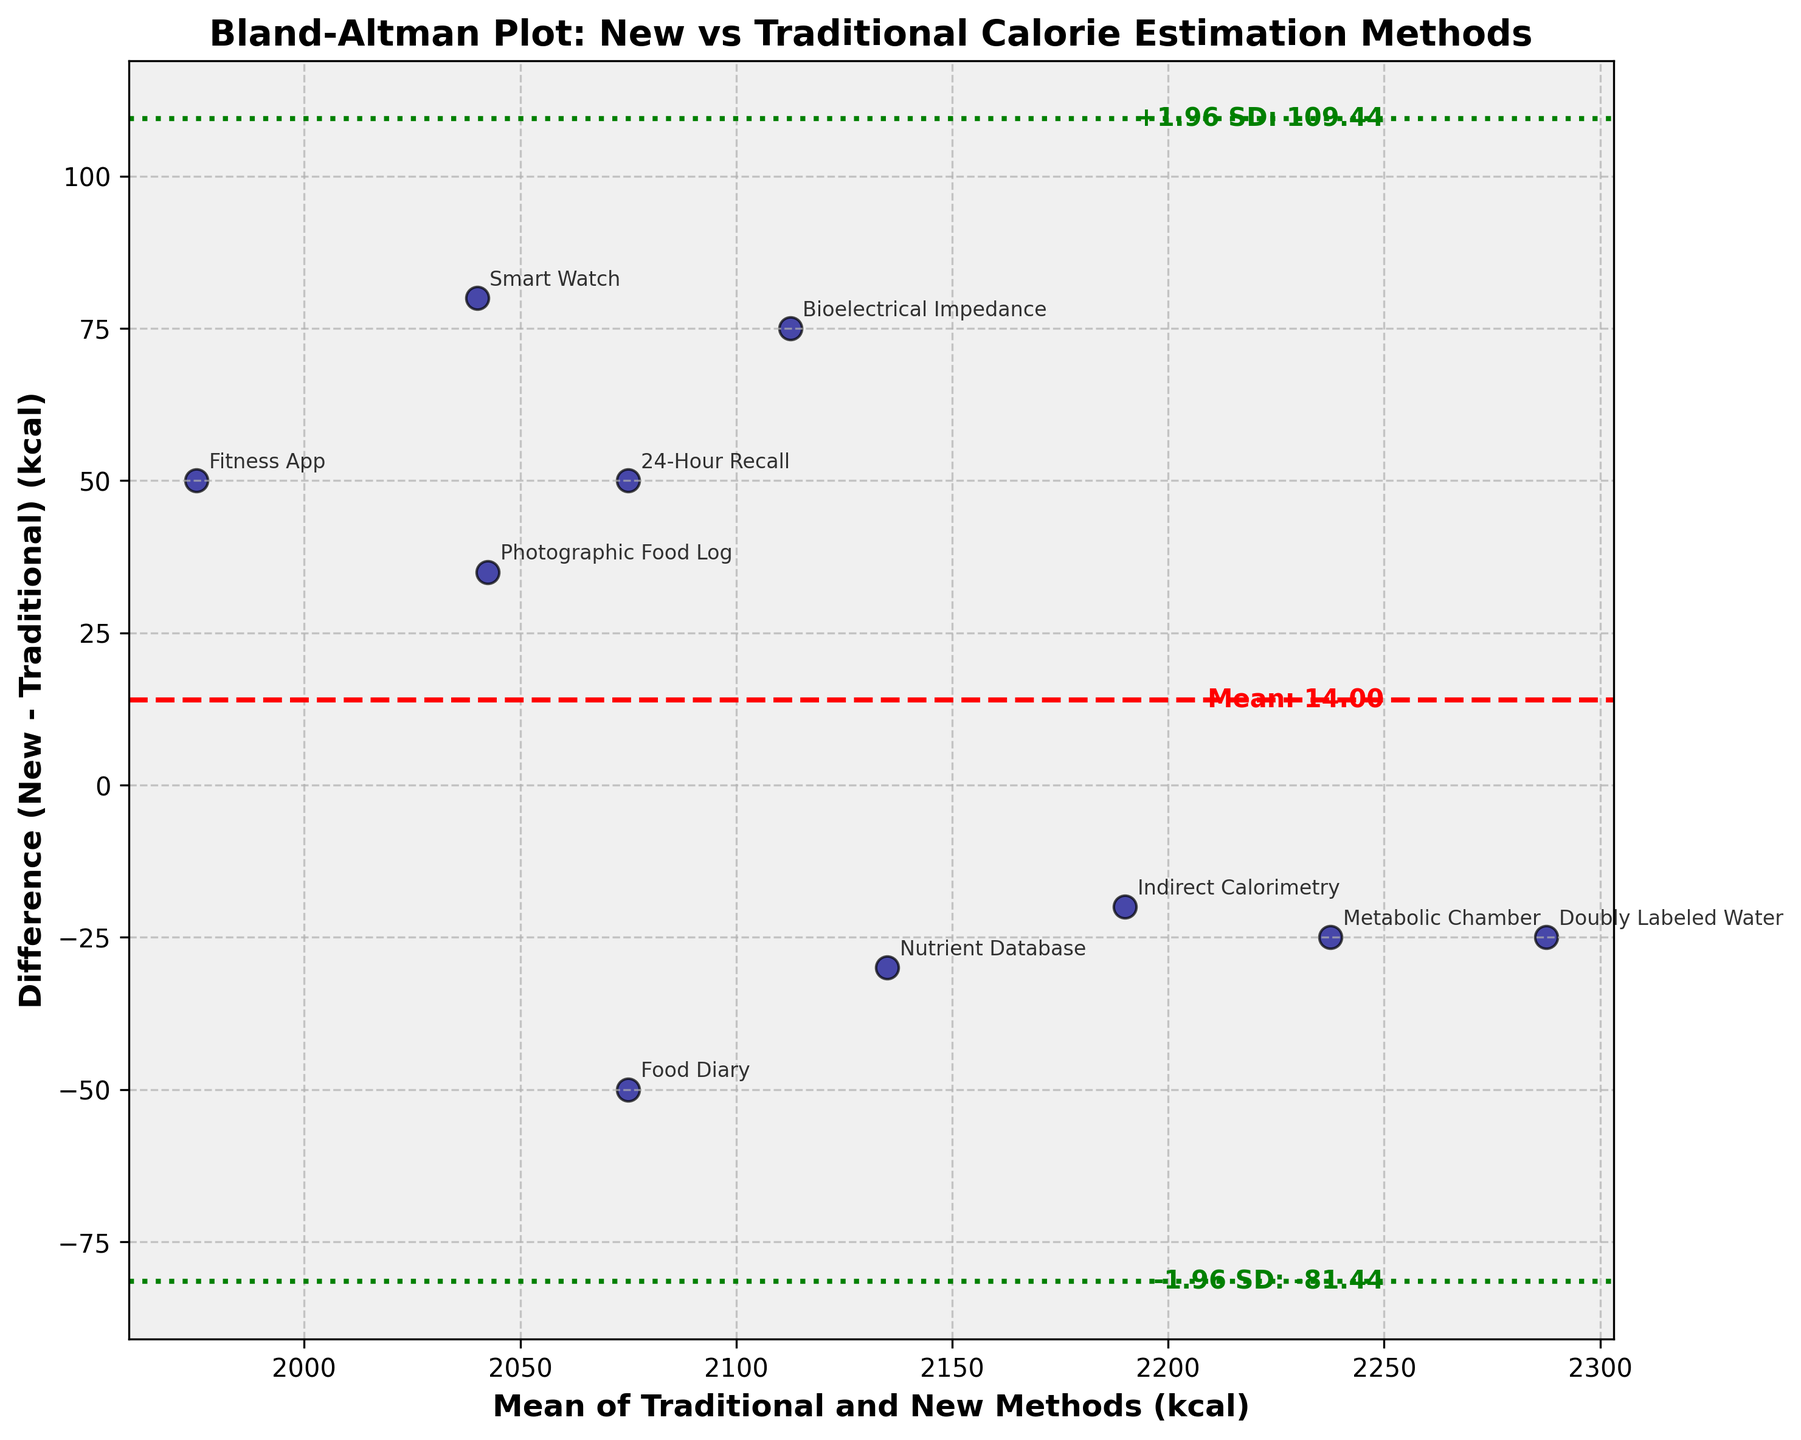What is the title of the plot? The title of the plot is usually found at the top and describes what the figure is about. Here, since the data compares new and traditional methods of estimating daily calorie intake, the title reflects this comparison.
Answer: Bland-Altman Plot: New vs Traditional Calorie Estimation Methods How many data points are plotted in the figure? To determine the number of data points, count the number of markers or points shown in the plot. Each point represents a pair of measurements from the dataset.
Answer: 10 What is the average difference between the new and traditional methods? The average difference is shown as a horizontal dashed red line in the plot. It is also annotated with "Mean" next to it.
Answer: -5.50 What do the green dotted lines represent? The green dotted lines represent the limits of agreement, which are ±1.96 times the standard deviation of the differences from the mean of the differences. These lines help determine the range within which most differences between the two methods lie.
Answer: Limits of agreement What is the range of the limits of agreement? The limits of agreement are calculated as Mean ± 1.96 * SD. These values are marked by green dotted lines and annotated on the plot.
Answer: (-134.86, 123.86) Which method has the largest positive difference between new and traditional estimates? Identify the highest point on the y-axis (Difference) and check the annotated method name next to it.
Answer: Bioelectrical Impedance What is the mean calorie value for the method with the smallest difference? Find the point with the smallest absolute difference on the y-axis. Then, read the mean value on the x-axis for this point. The smallest difference is at the bottom of the plot.
Answer: 2287.5 How does the difference between methods vary with mean calorie intake? Observe the scatter of points relative to the mean calorie values on the x-axis and differences on the y-axis. Check if there's any trend or pattern, such as the differences increasing with mean calorie values or remaining random.
Answer: Varies randomly Does any method show an outlier difference? Spot the point(s) that lie outside the limits of agreement (green dotted lines). These points indicate significant disagreement between methods.
Answer: No Which method has the mean closest to 2100 kcal? Look at the points scattered around the mean calorie intake of 2100 kcal on the x-axis, and identify the closest method by checking the annotations.
Answer: Photographic Food Log 